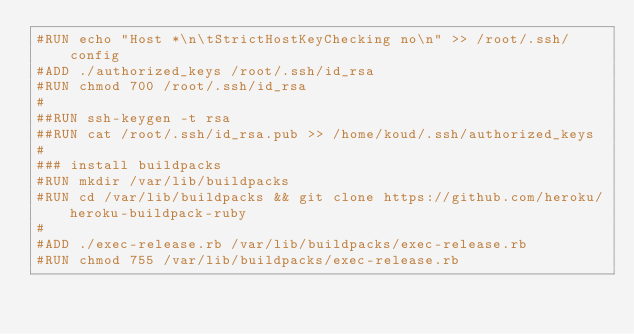Convert code to text. <code><loc_0><loc_0><loc_500><loc_500><_Dockerfile_>#RUN echo "Host *\n\tStrictHostKeyChecking no\n" >> /root/.ssh/config
#ADD ./authorized_keys /root/.ssh/id_rsa
#RUN chmod 700 /root/.ssh/id_rsa
#
##RUN ssh-keygen -t rsa
##RUN cat /root/.ssh/id_rsa.pub >> /home/koud/.ssh/authorized_keys
#
### install buildpacks
#RUN mkdir /var/lib/buildpacks
#RUN cd /var/lib/buildpacks && git clone https://github.com/heroku/heroku-buildpack-ruby
#
#ADD ./exec-release.rb /var/lib/buildpacks/exec-release.rb
#RUN chmod 755 /var/lib/buildpacks/exec-release.rb
</code> 